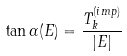Convert formula to latex. <formula><loc_0><loc_0><loc_500><loc_500>\tan \alpha ( E ) = \frac { T _ { k } ^ { ( i m p ) } } { \left | E \right | }</formula> 